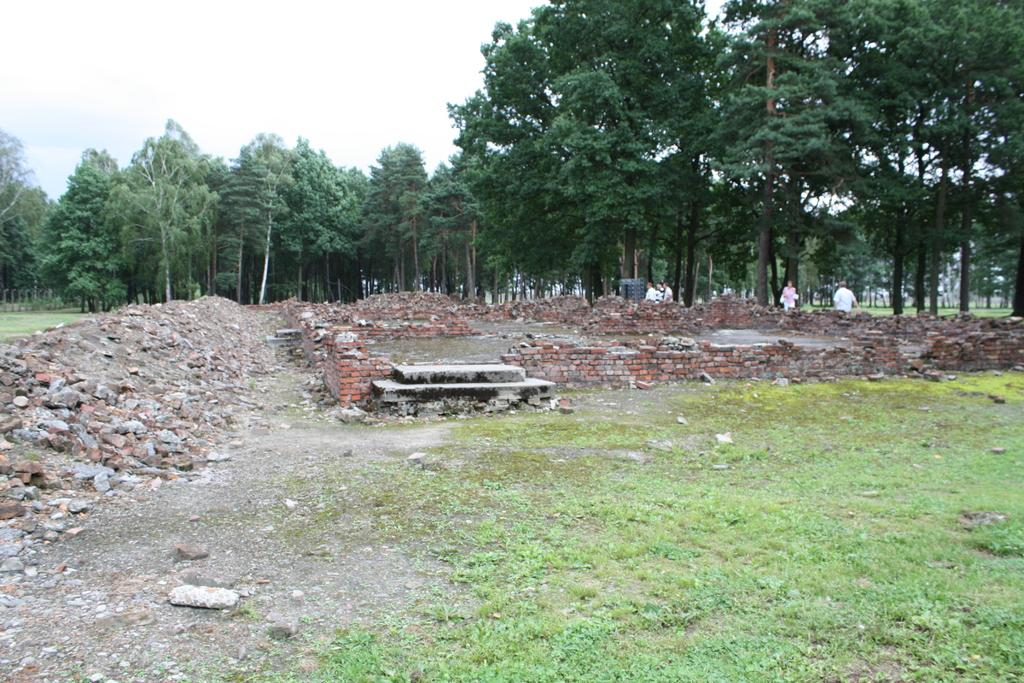What can be seen in the right corner of the image? There are persons standing in the right corner of the image. What objects are located near the persons? There are bricks beside the persons. What type of natural scenery is visible in the background of the image? There are trees in the background of the image. What type of lettuce can be seen in the image? There is no lettuce present in the image. 